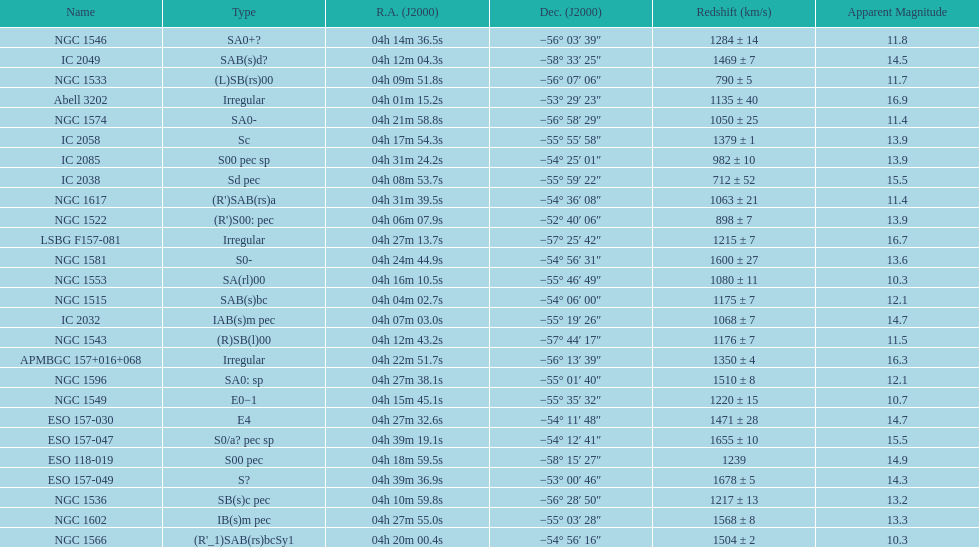Can you parse all the data within this table? {'header': ['Name', 'Type', 'R.A. (J2000)', 'Dec. (J2000)', 'Redshift (km/s)', 'Apparent Magnitude'], 'rows': [['NGC 1546', 'SA0+?', '04h\xa014m\xa036.5s', '−56°\xa003′\xa039″', '1284 ± 14', '11.8'], ['IC 2049', 'SAB(s)d?', '04h\xa012m\xa004.3s', '−58°\xa033′\xa025″', '1469 ± 7', '14.5'], ['NGC 1533', '(L)SB(rs)00', '04h\xa009m\xa051.8s', '−56°\xa007′\xa006″', '790 ± 5', '11.7'], ['Abell 3202', 'Irregular', '04h\xa001m\xa015.2s', '−53°\xa029′\xa023″', '1135 ± 40', '16.9'], ['NGC 1574', 'SA0-', '04h\xa021m\xa058.8s', '−56°\xa058′\xa029″', '1050 ± 25', '11.4'], ['IC 2058', 'Sc', '04h\xa017m\xa054.3s', '−55°\xa055′\xa058″', '1379 ± 1', '13.9'], ['IC 2085', 'S00 pec sp', '04h\xa031m\xa024.2s', '−54°\xa025′\xa001″', '982 ± 10', '13.9'], ['IC 2038', 'Sd pec', '04h\xa008m\xa053.7s', '−55°\xa059′\xa022″', '712 ± 52', '15.5'], ['NGC 1617', "(R')SAB(rs)a", '04h\xa031m\xa039.5s', '−54°\xa036′\xa008″', '1063 ± 21', '11.4'], ['NGC 1522', "(R')S00: pec", '04h\xa006m\xa007.9s', '−52°\xa040′\xa006″', '898 ± 7', '13.9'], ['LSBG F157-081', 'Irregular', '04h\xa027m\xa013.7s', '−57°\xa025′\xa042″', '1215 ± 7', '16.7'], ['NGC 1581', 'S0-', '04h\xa024m\xa044.9s', '−54°\xa056′\xa031″', '1600 ± 27', '13.6'], ['NGC 1553', 'SA(rl)00', '04h\xa016m\xa010.5s', '−55°\xa046′\xa049″', '1080 ± 11', '10.3'], ['NGC 1515', 'SAB(s)bc', '04h\xa004m\xa002.7s', '−54°\xa006′\xa000″', '1175 ± 7', '12.1'], ['IC 2032', 'IAB(s)m pec', '04h\xa007m\xa003.0s', '−55°\xa019′\xa026″', '1068 ± 7', '14.7'], ['NGC 1543', '(R)SB(l)00', '04h\xa012m\xa043.2s', '−57°\xa044′\xa017″', '1176 ± 7', '11.5'], ['APMBGC 157+016+068', 'Irregular', '04h\xa022m\xa051.7s', '−56°\xa013′\xa039″', '1350 ± 4', '16.3'], ['NGC 1596', 'SA0: sp', '04h\xa027m\xa038.1s', '−55°\xa001′\xa040″', '1510 ± 8', '12.1'], ['NGC 1549', 'E0−1', '04h\xa015m\xa045.1s', '−55°\xa035′\xa032″', '1220 ± 15', '10.7'], ['ESO 157-030', 'E4', '04h\xa027m\xa032.6s', '−54°\xa011′\xa048″', '1471 ± 28', '14.7'], ['ESO 157-047', 'S0/a? pec sp', '04h\xa039m\xa019.1s', '−54°\xa012′\xa041″', '1655 ± 10', '15.5'], ['ESO 118-019', 'S00 pec', '04h\xa018m\xa059.5s', '−58°\xa015′\xa027″', '1239', '14.9'], ['ESO 157-049', 'S?', '04h\xa039m\xa036.9s', '−53°\xa000′\xa046″', '1678 ± 5', '14.3'], ['NGC 1536', 'SB(s)c pec', '04h\xa010m\xa059.8s', '−56°\xa028′\xa050″', '1217 ± 13', '13.2'], ['NGC 1602', 'IB(s)m pec', '04h\xa027m\xa055.0s', '−55°\xa003′\xa028″', '1568 ± 8', '13.3'], ['NGC 1566', "(R'_1)SAB(rs)bcSy1", '04h\xa020m\xa000.4s', '−54°\xa056′\xa016″', '1504 ± 2', '10.3']]} Name the member with the highest apparent magnitude. Abell 3202. 